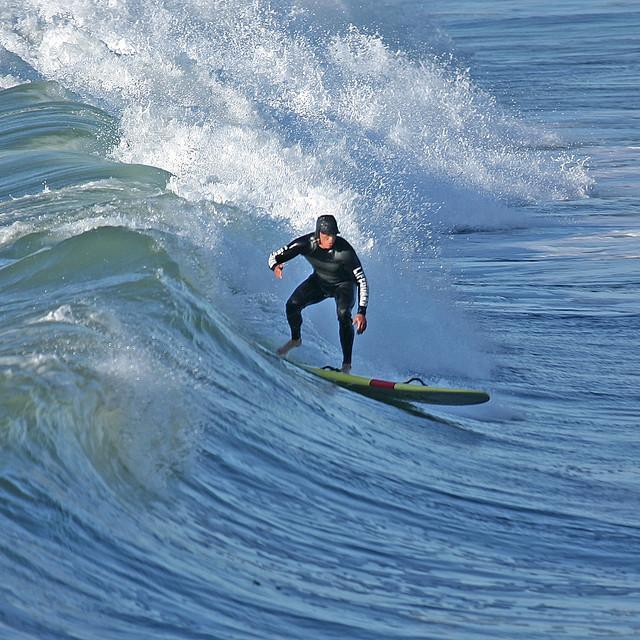How many trucks are in the photo?
Give a very brief answer. 0. 